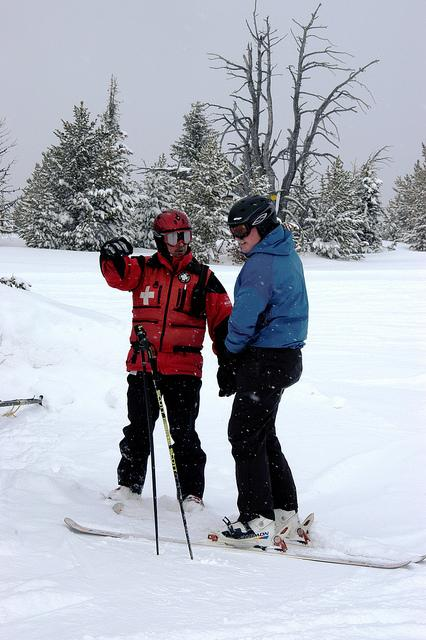What does the man in the red jacket's patch indicate?

Choices:
A) emergency personnel
B) police
C) fire fighter
D) us military emergency personnel 